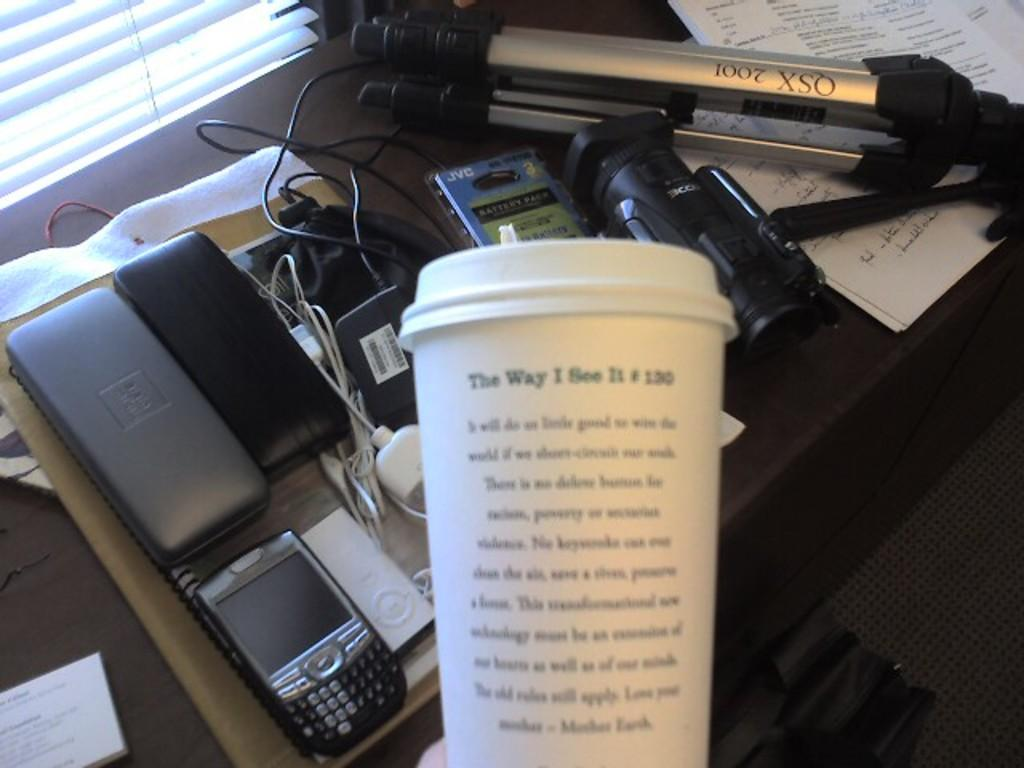<image>
Write a terse but informative summary of the picture. The white cup has the words the way i see it written on it. 